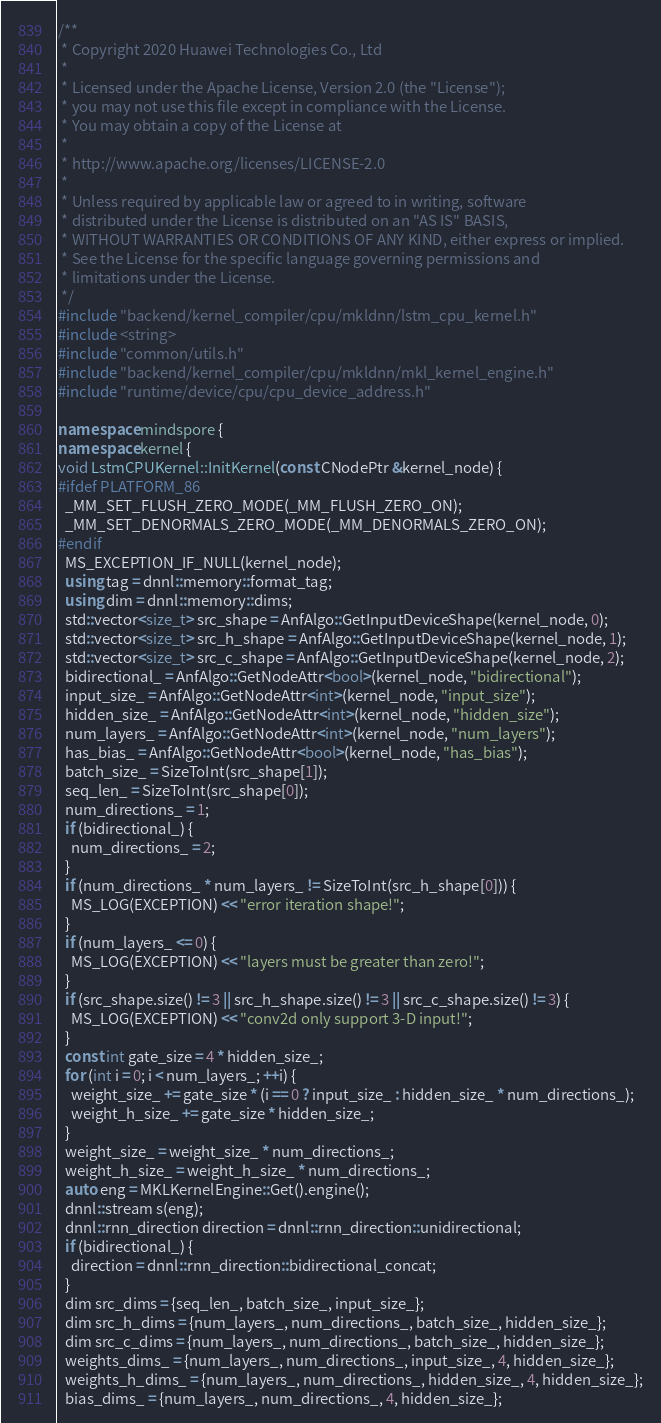Convert code to text. <code><loc_0><loc_0><loc_500><loc_500><_C++_>/**
 * Copyright 2020 Huawei Technologies Co., Ltd
 *
 * Licensed under the Apache License, Version 2.0 (the "License");
 * you may not use this file except in compliance with the License.
 * You may obtain a copy of the License at
 *
 * http://www.apache.org/licenses/LICENSE-2.0
 *
 * Unless required by applicable law or agreed to in writing, software
 * distributed under the License is distributed on an "AS IS" BASIS,
 * WITHOUT WARRANTIES OR CONDITIONS OF ANY KIND, either express or implied.
 * See the License for the specific language governing permissions and
 * limitations under the License.
 */
#include "backend/kernel_compiler/cpu/mkldnn/lstm_cpu_kernel.h"
#include <string>
#include "common/utils.h"
#include "backend/kernel_compiler/cpu/mkldnn/mkl_kernel_engine.h"
#include "runtime/device/cpu/cpu_device_address.h"

namespace mindspore {
namespace kernel {
void LstmCPUKernel::InitKernel(const CNodePtr &kernel_node) {
#ifdef PLATFORM_86
  _MM_SET_FLUSH_ZERO_MODE(_MM_FLUSH_ZERO_ON);
  _MM_SET_DENORMALS_ZERO_MODE(_MM_DENORMALS_ZERO_ON);
#endif
  MS_EXCEPTION_IF_NULL(kernel_node);
  using tag = dnnl::memory::format_tag;
  using dim = dnnl::memory::dims;
  std::vector<size_t> src_shape = AnfAlgo::GetInputDeviceShape(kernel_node, 0);
  std::vector<size_t> src_h_shape = AnfAlgo::GetInputDeviceShape(kernel_node, 1);
  std::vector<size_t> src_c_shape = AnfAlgo::GetInputDeviceShape(kernel_node, 2);
  bidirectional_ = AnfAlgo::GetNodeAttr<bool>(kernel_node, "bidirectional");
  input_size_ = AnfAlgo::GetNodeAttr<int>(kernel_node, "input_size");
  hidden_size_ = AnfAlgo::GetNodeAttr<int>(kernel_node, "hidden_size");
  num_layers_ = AnfAlgo::GetNodeAttr<int>(kernel_node, "num_layers");
  has_bias_ = AnfAlgo::GetNodeAttr<bool>(kernel_node, "has_bias");
  batch_size_ = SizeToInt(src_shape[1]);
  seq_len_ = SizeToInt(src_shape[0]);
  num_directions_ = 1;
  if (bidirectional_) {
    num_directions_ = 2;
  }
  if (num_directions_ * num_layers_ != SizeToInt(src_h_shape[0])) {
    MS_LOG(EXCEPTION) << "error iteration shape!";
  }
  if (num_layers_ <= 0) {
    MS_LOG(EXCEPTION) << "layers must be greater than zero!";
  }
  if (src_shape.size() != 3 || src_h_shape.size() != 3 || src_c_shape.size() != 3) {
    MS_LOG(EXCEPTION) << "conv2d only support 3-D input!";
  }
  const int gate_size = 4 * hidden_size_;
  for (int i = 0; i < num_layers_; ++i) {
    weight_size_ += gate_size * (i == 0 ? input_size_ : hidden_size_ * num_directions_);
    weight_h_size_ += gate_size * hidden_size_;
  }
  weight_size_ = weight_size_ * num_directions_;
  weight_h_size_ = weight_h_size_ * num_directions_;
  auto eng = MKLKernelEngine::Get().engine();
  dnnl::stream s(eng);
  dnnl::rnn_direction direction = dnnl::rnn_direction::unidirectional;
  if (bidirectional_) {
    direction = dnnl::rnn_direction::bidirectional_concat;
  }
  dim src_dims = {seq_len_, batch_size_, input_size_};
  dim src_h_dims = {num_layers_, num_directions_, batch_size_, hidden_size_};
  dim src_c_dims = {num_layers_, num_directions_, batch_size_, hidden_size_};
  weights_dims_ = {num_layers_, num_directions_, input_size_, 4, hidden_size_};
  weights_h_dims_ = {num_layers_, num_directions_, hidden_size_, 4, hidden_size_};
  bias_dims_ = {num_layers_, num_directions_, 4, hidden_size_};</code> 